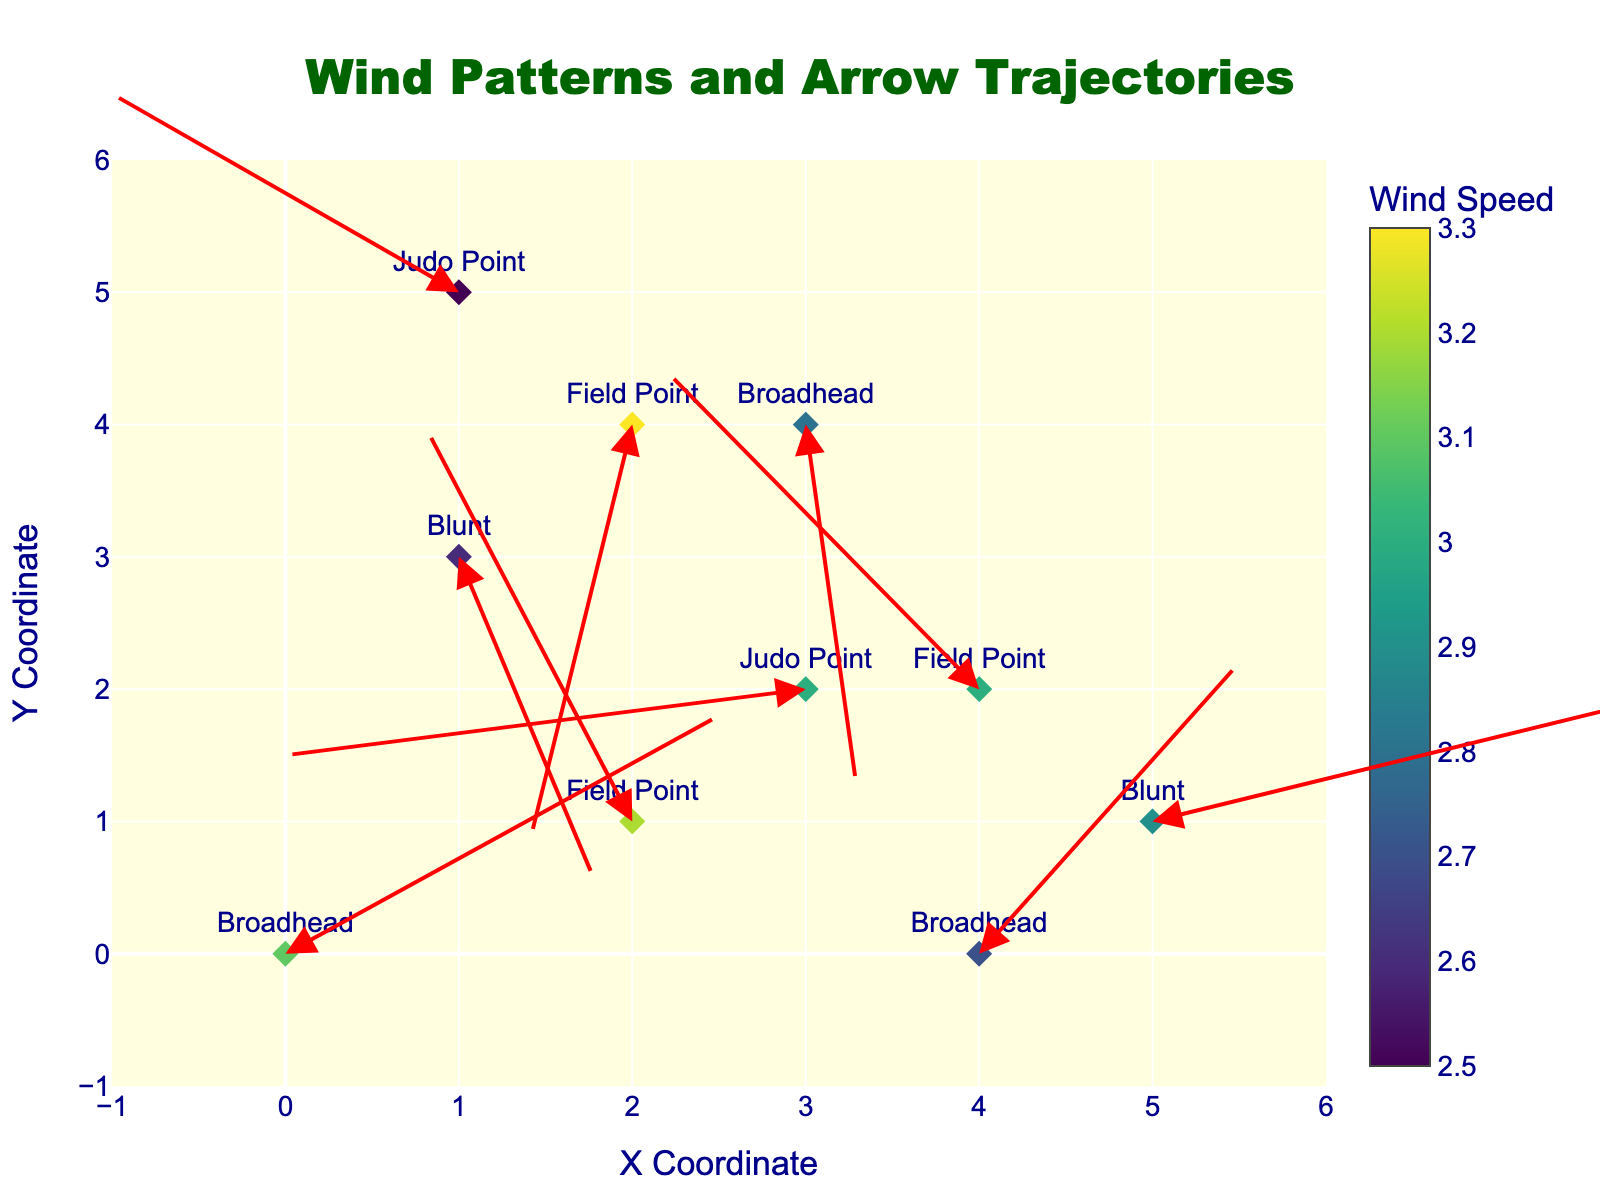What is the title of the figure? The text at the top center of the figure clearly states the title, which is in dark green color and large font size.
Answer: Wind Patterns and Arrow Trajectories How many different types of arrows are represented in the figure? By examining the labels next to each marker, we can identify that there are four distinct types of arrows: "Broadhead," "Field Point," "Blunt," and "Judo Point."
Answer: 4 What is the wind speed at coordinates (2, 1)? Looking at the marker at coordinates (2, 1), the hovertext or the color corresponding to the colorbar indicates that the wind speed is 3.2.
Answer: 3.2 Which arrow type experiences the highest wind speed, and what is that speed? By checking the hovertext for each marker, the "Field Point" arrow at (2, 4) has the highest wind speed, which is 3.3.
Answer: Field Point, 3.3 What are the U and V components of wind for the arrow at coordinates (4, 2)? By examining the arrow's direction and length at coordinates (4, 2), the label or hovertext indicates U = -1.8 and V = 2.4.
Answer: U = -1.8, V = 2.4 Which arrow type deviates most due to the wind, and by how much (in terms of the combined vector magnitude of U and V)? The arrow type "Blunt" at (1, 3) has a U component of 0.8 and a V component of -2.5. Calculating the vector magnitude: sqrt((0.8)^2 + (-2.5)^2) ≈ 2.62. Comparing the magnitudes for all arrows, the "Blunt" at (1, 3) shows the most deviation.
Answer: Blunt, 2.62 Which arrow has the least deviation due to wind? By calculating the vector magnitudes for all arrows, the "Broadhead" at (3, 4) with U = 0.3 and V = -2.8 gives a magnitude of sqrt((0.3)^2 + (-2.8)^2) ≈ 2.82, which is not the least. "Field Point" at (2, 1) with U = -1.2 and V = 3.0 gives a magnitude of sqrt((-1.2)^2 + (3.0)^2) ≈ 3.16. Comparing all, "Judo Point" at (3, 2) with U = -3.0 and V = -0.5 gives the least deviation.
Answer: Judo Point, 3.04 How does the wind pattern at coordinates (0, 0) affect the arrow trajectory of the "Broadhead"? The arrow originating from (0, 0) with U = 2.5 and V = 1.8 will be pushed significantly to the right and slightly upwards, making an impact on the trajectory.
Answer: Right and upwards Which coordinate experiences the weakest wind speed, and what is that speed? Examining the color intensity of markers and using the colorbar scale, the "Judo Point" at (1, 5) corresponds to the lowest wind speed of 2.5.
Answer: (1, 5), 2.5 